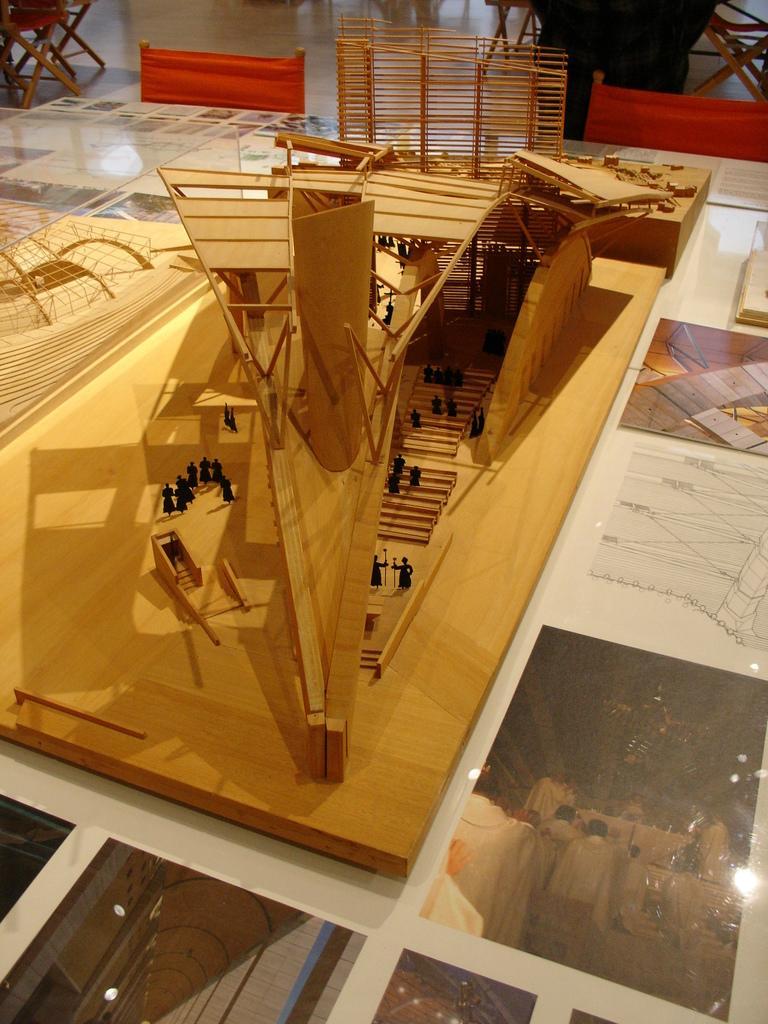Describe this image in one or two sentences. In this image there are persons on the wooden floor, there are person standing and holding objects, there are photo frames on the ground, there are objects on the floor, there is an object truncated towards the left of the image, there is an object truncated towards the right of the image. 